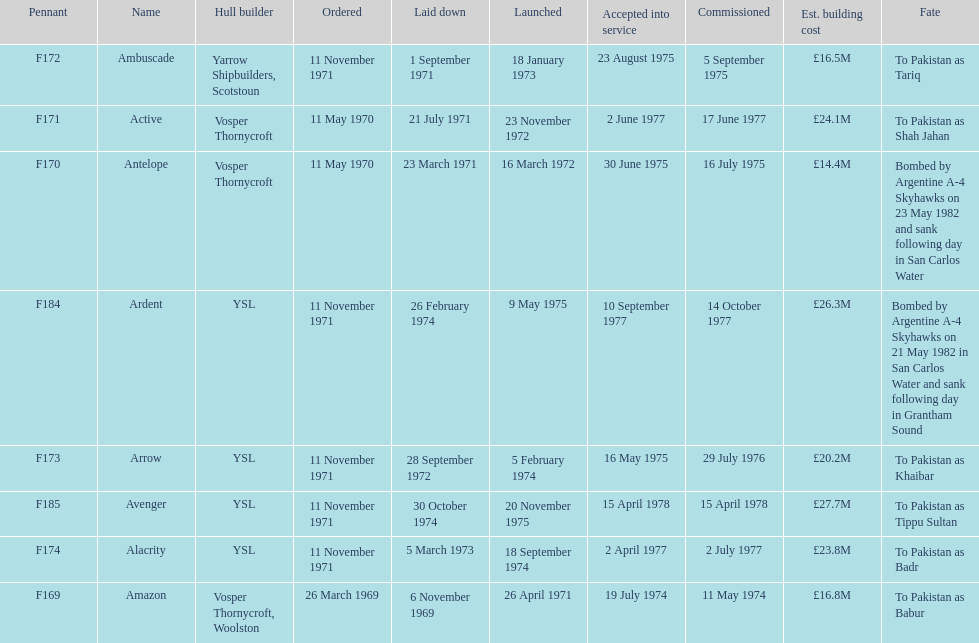Before the arrow's order on november 11, 1971, which ship came prior to it? Ambuscade. 